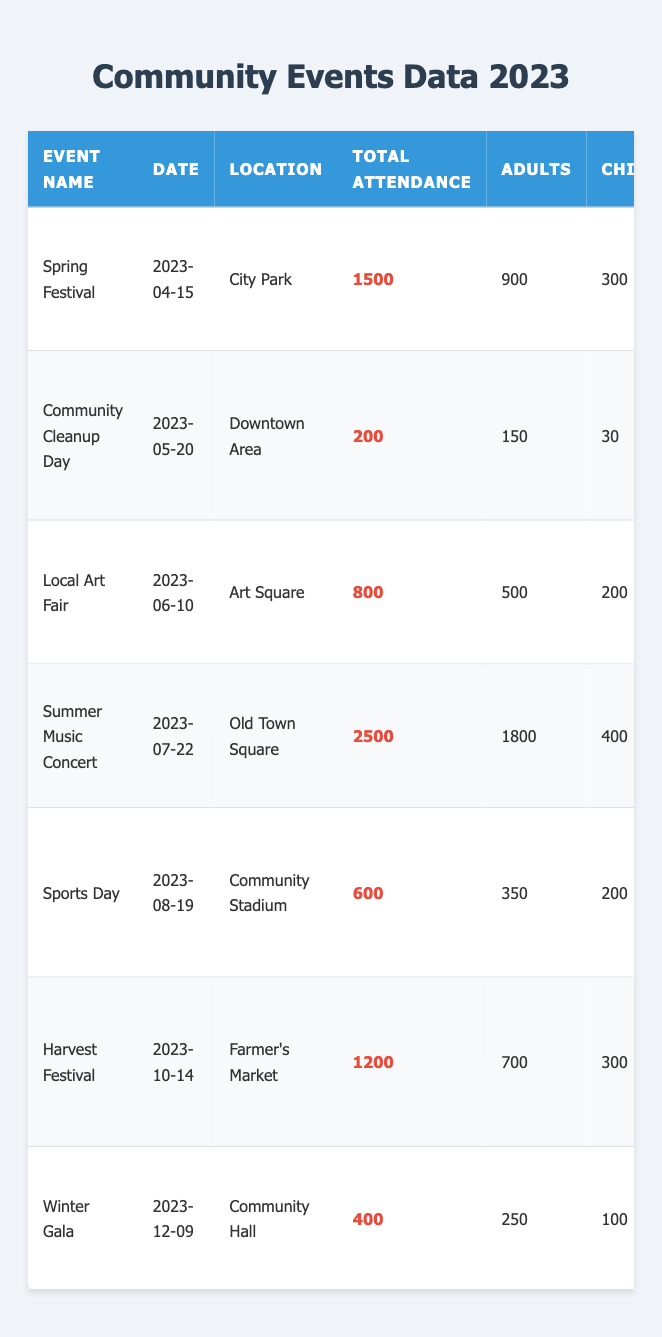What is the total attendance for the Summer Music Concert? The table shows the total attendance for each event. For the Summer Music Concert, the attendance is directly noted as 2500.
Answer: 2500 How many adults attended the Harvest Festival? The table provides a breakdown of participants by type for each event. For the Harvest Festival, the number of adults is listed as 700.
Answer: 700 What activities took place during the Community Cleanup Day? The activities for each event are listed under the "Activities" column. For the Community Cleanup Day, the activities are Litter Pickup, Tree Planting, and Community Lunch.
Answer: Litter Pickup, Tree Planting, Community Lunch Is the total attendance for the Winter Gala greater than 500? The total attendance for the Winter Gala is listed as 400 in the table, which is less than 500.
Answer: No What is the average total attendance across all events? The total attendance values are 1500, 200, 800, 2500, 600, 1200, and 400. Adding these gives 5200, and there are 7 events, so the average is 5200/7 ≈ 742.86.
Answer: 742.86 How many more adults attended the Summer Music Concert than the Spring Festival? The number of adults at the Summer Music Concert is 1800, and for the Spring Festival, it is 900. The difference is 1800 - 900 = 900.
Answer: 900 List all events that had more than 1000 in total attendance. By checking the total attendance for each event, the events with more than 1000 attendees are the Summer Music Concert (2500), Spring Festival (1500), and Harvest Festival (1200).
Answer: Summer Music Concert, Spring Festival, Harvest Festival Which event had the least number of attendees and what was the date? The event with the least total attendance is the Community Cleanup Day, which had 200 attendees, and it occurred on May 20, 2023.
Answer: Community Cleanup Day on 2023-05-20 What is the total number of volunteer hours contributed to all events? Summing the volunteer hours for each event: 120 + 60 + 90 + 150 + 80 + 100 + 50 = 650 volunteer hours in total.
Answer: 650 Which event had the highest number of children participants? The attendance for children is listed for each event. The event with the highest number of children participants is the Summer Music Concert with 400 participants.
Answer: Summer Music Concert with 400 children participants What percentage of the Summer Music Concert attendees were adults? Total attendance for the Summer Music Concert is 2500, with 1800 of them adults. The percentage is calculated as (1800 / 2500) * 100 = 72%.
Answer: 72% How many total senior participants were recorded in the Local Art Fair and Sports Day combined? The number of seniors is 100 for the Local Art Fair and 50 for Sports Day, so combining them gives 100 + 50 = 150 seniors.
Answer: 150 Which event occurred last in the year and what activities were planned? The last event in the year is the Winter Gala, and the planned activities are Formal Dinner, Silent Auction, and Live Auction.
Answer: Winter Gala with activities Formal Dinner, Silent Auction, Live Auction 